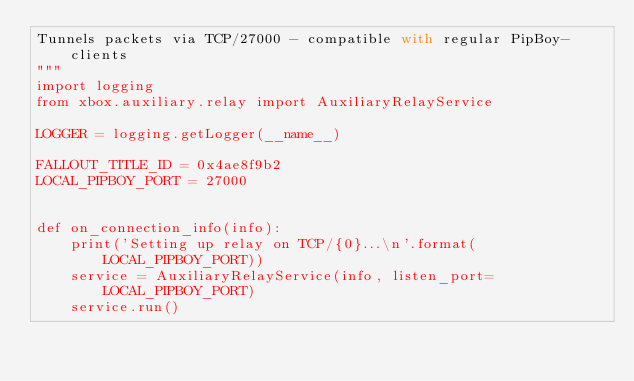Convert code to text. <code><loc_0><loc_0><loc_500><loc_500><_Python_>Tunnels packets via TCP/27000 - compatible with regular PipBoy-clients
"""
import logging
from xbox.auxiliary.relay import AuxiliaryRelayService

LOGGER = logging.getLogger(__name__)

FALLOUT_TITLE_ID = 0x4ae8f9b2
LOCAL_PIPBOY_PORT = 27000


def on_connection_info(info):
    print('Setting up relay on TCP/{0}...\n'.format(LOCAL_PIPBOY_PORT))
    service = AuxiliaryRelayService(info, listen_port=LOCAL_PIPBOY_PORT)
    service.run()
</code> 